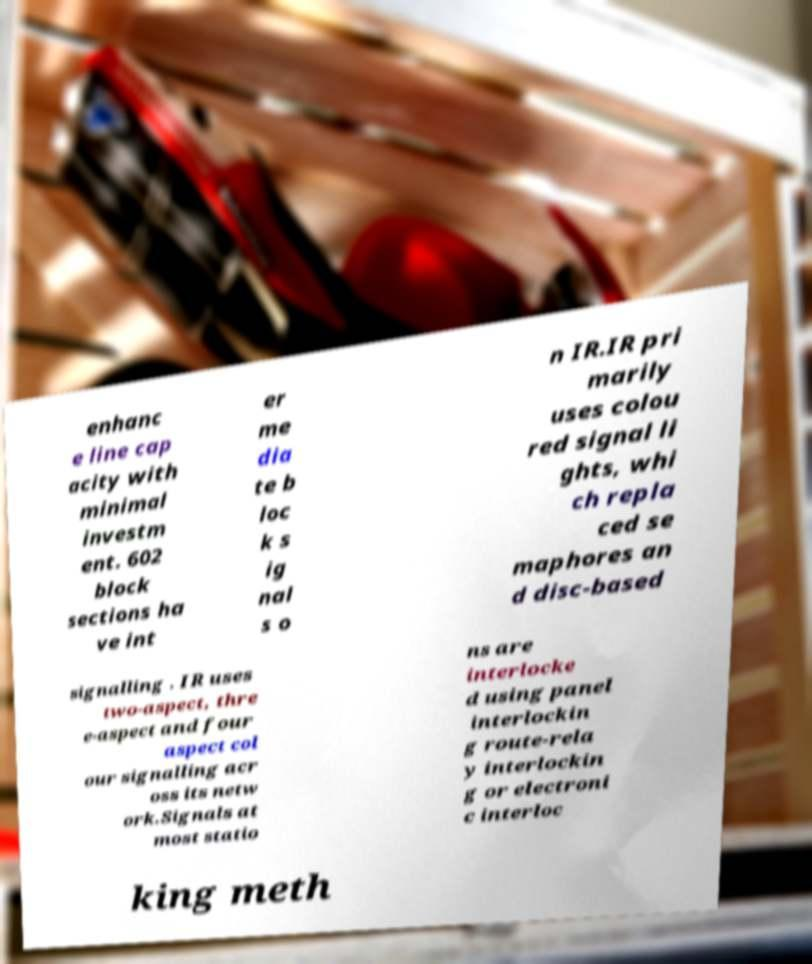Please identify and transcribe the text found in this image. enhanc e line cap acity with minimal investm ent. 602 block sections ha ve int er me dia te b loc k s ig nal s o n IR.IR pri marily uses colou red signal li ghts, whi ch repla ced se maphores an d disc-based signalling . IR uses two-aspect, thre e-aspect and four aspect col our signalling acr oss its netw ork.Signals at most statio ns are interlocke d using panel interlockin g route-rela y interlockin g or electroni c interloc king meth 